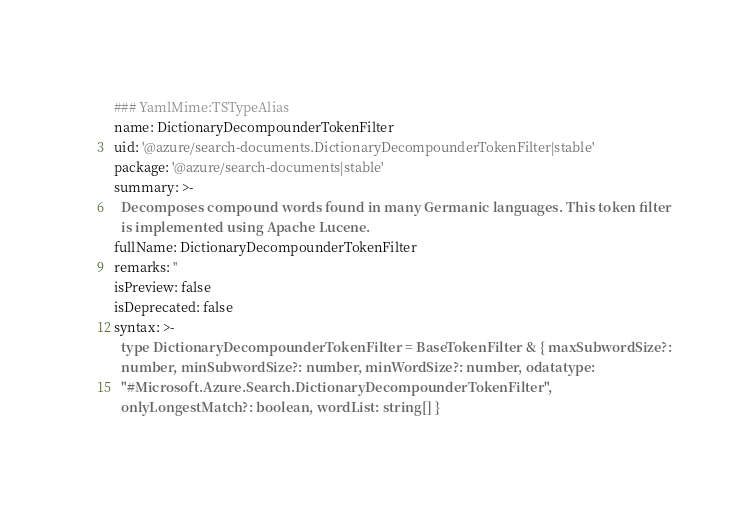<code> <loc_0><loc_0><loc_500><loc_500><_YAML_>### YamlMime:TSTypeAlias
name: DictionaryDecompounderTokenFilter
uid: '@azure/search-documents.DictionaryDecompounderTokenFilter|stable'
package: '@azure/search-documents|stable'
summary: >-
  Decomposes compound words found in many Germanic languages. This token filter
  is implemented using Apache Lucene.
fullName: DictionaryDecompounderTokenFilter
remarks: ''
isPreview: false
isDeprecated: false
syntax: >-
  type DictionaryDecompounderTokenFilter = BaseTokenFilter & { maxSubwordSize?:
  number, minSubwordSize?: number, minWordSize?: number, odatatype:
  "#Microsoft.Azure.Search.DictionaryDecompounderTokenFilter",
  onlyLongestMatch?: boolean, wordList: string[] }
</code> 